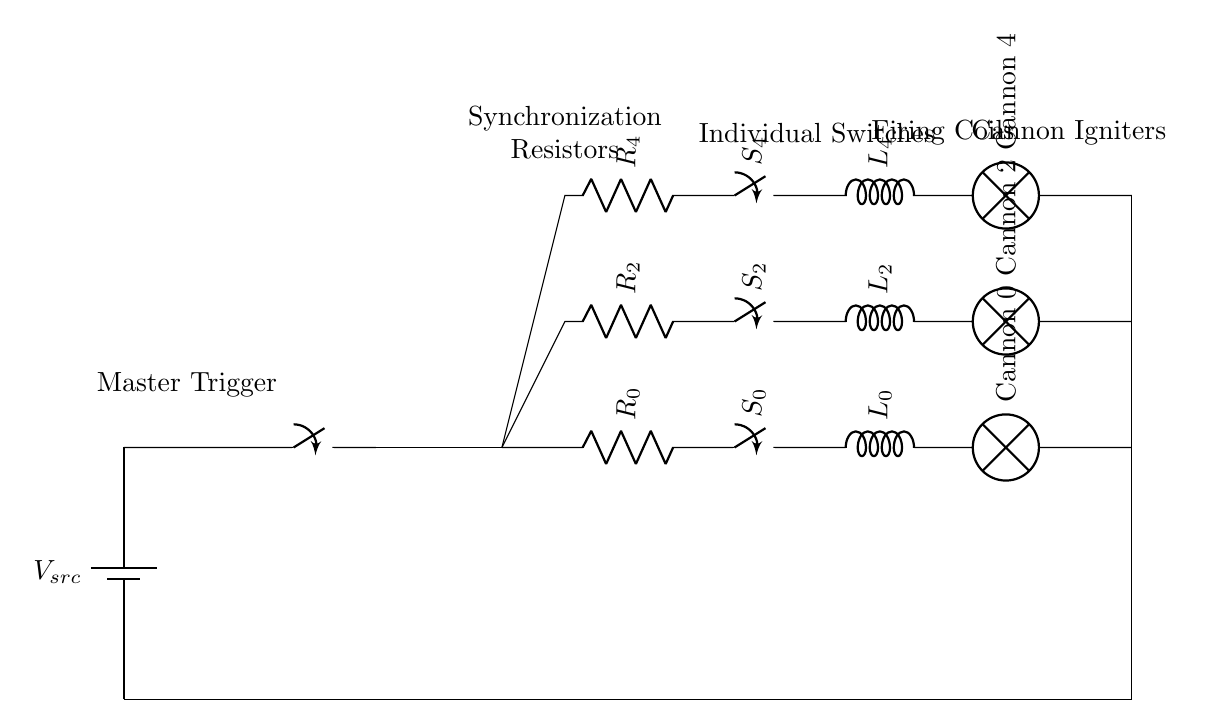What is the main power source of this circuit? The main power source is labeled as V_src, which indicates it is a battery providing voltage to the circuit.
Answer: V_src How many cannon circuits are present in this schematic? The schematic shows three individual cannon firing circuits clearly depicted vertically along the right side of the diagram.
Answer: Three What component is used to synchronize the firings of the cannons? The synchronization is achieved through a master trigger mechanism depicted as a switch connected to a distribution line that feeds to all individual circuits.
Answer: Master Trigger What do the resistors labeled R_y represent in the circuit? The resistors labeled R_y are considered synchronization resistors that help control the current in each cannon's firing circuit to ensure synchronized operation.
Answer: Synchronization Resistors What type of switch is used for each cannon's firing circuit? The circuit employs individual closing switches labeled S_y for each cannon, indicating that these are simple on/off switches that control the firing mechanism.
Answer: Closing Switches Explain how the circuits are grounded. The grounding is achieved by connecting each cannon circuit to a common ground, indicated by lines drawn from the endpoints of the cannon circuits vertically down to a common point, which returns to the main battery ground.
Answer: Common Ground 